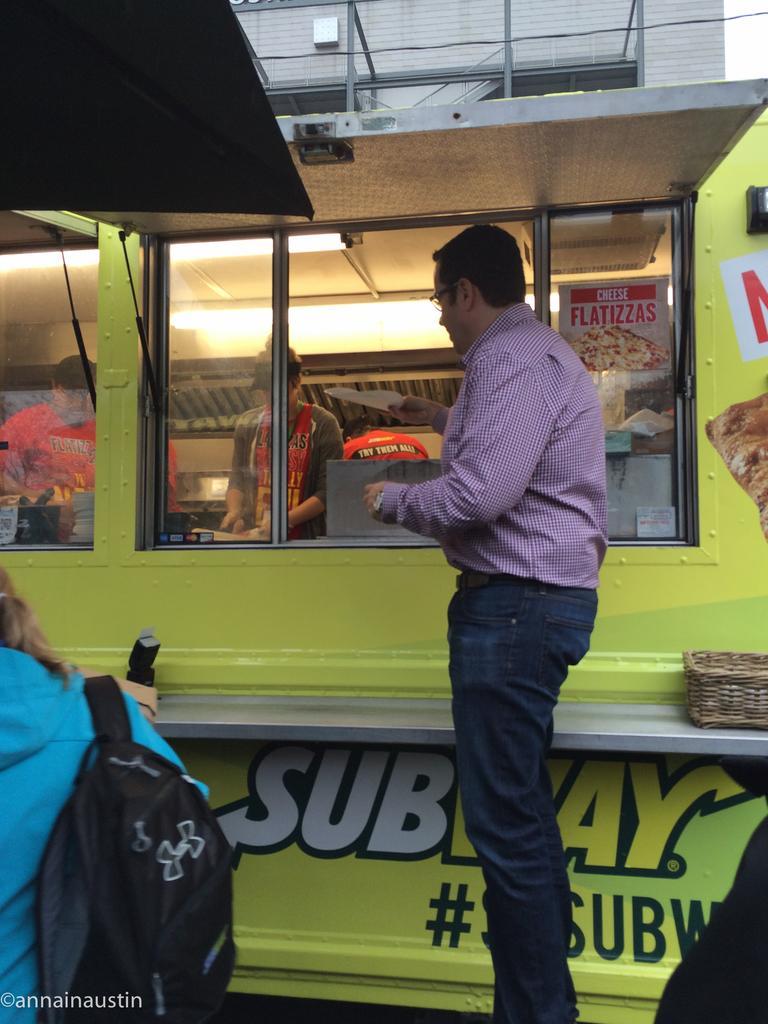How would you summarize this image in a sentence or two? In this image in the foreground there is one person standing and there is a truck, in the truck there are some people preparing food and there are some vessels, lights and objects and there are glass windows. On the windows there are some posters, on the right side there is a basket and on the left there is another person who is wearing a bag. And in the background there is a building and wires, and in the top left hand corner there is a roof. 